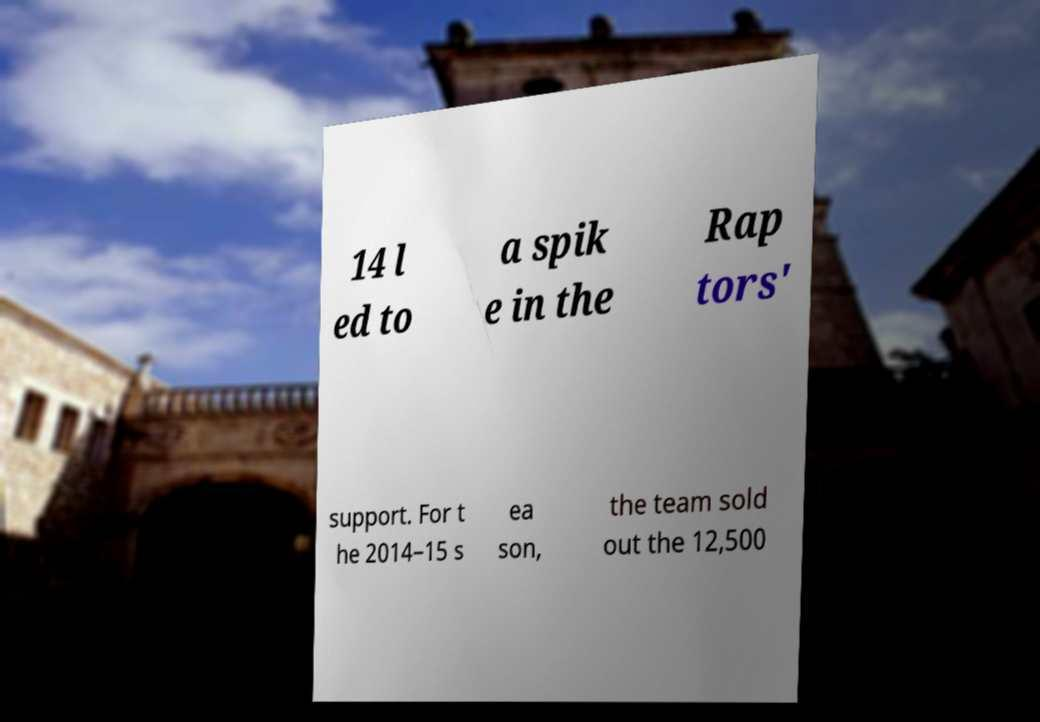Please read and relay the text visible in this image. What does it say? 14 l ed to a spik e in the Rap tors' support. For t he 2014–15 s ea son, the team sold out the 12,500 